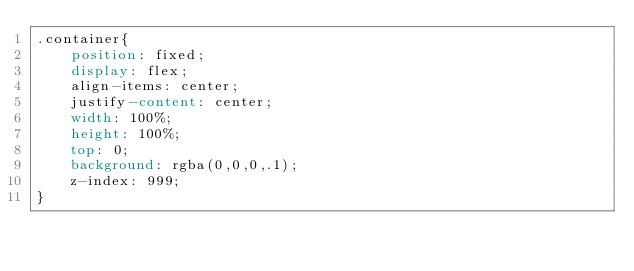<code> <loc_0><loc_0><loc_500><loc_500><_CSS_>.container{
    position: fixed;
    display: flex;
    align-items: center;
    justify-content: center;
    width: 100%;
    height: 100%;
    top: 0;
    background: rgba(0,0,0,.1);
    z-index: 999;
}</code> 